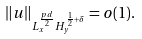<formula> <loc_0><loc_0><loc_500><loc_500>\| u \| _ { L _ { x } ^ { \frac { p d } { 2 } } H _ { y } ^ { \frac { 1 } { 2 } + \delta } } = o ( 1 ) .</formula> 